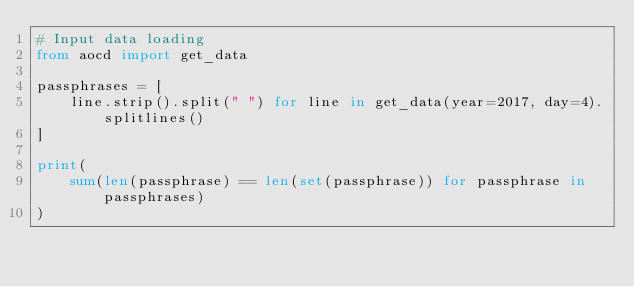<code> <loc_0><loc_0><loc_500><loc_500><_Python_># Input data loading
from aocd import get_data

passphrases = [
    line.strip().split(" ") for line in get_data(year=2017, day=4).splitlines()
]

print(
    sum(len(passphrase) == len(set(passphrase)) for passphrase in passphrases)
)
</code> 